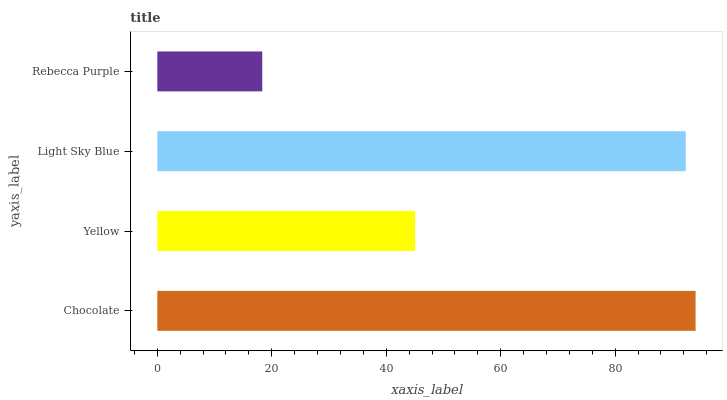Is Rebecca Purple the minimum?
Answer yes or no. Yes. Is Chocolate the maximum?
Answer yes or no. Yes. Is Yellow the minimum?
Answer yes or no. No. Is Yellow the maximum?
Answer yes or no. No. Is Chocolate greater than Yellow?
Answer yes or no. Yes. Is Yellow less than Chocolate?
Answer yes or no. Yes. Is Yellow greater than Chocolate?
Answer yes or no. No. Is Chocolate less than Yellow?
Answer yes or no. No. Is Light Sky Blue the high median?
Answer yes or no. Yes. Is Yellow the low median?
Answer yes or no. Yes. Is Yellow the high median?
Answer yes or no. No. Is Rebecca Purple the low median?
Answer yes or no. No. 